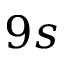<formula> <loc_0><loc_0><loc_500><loc_500>9 s</formula> 